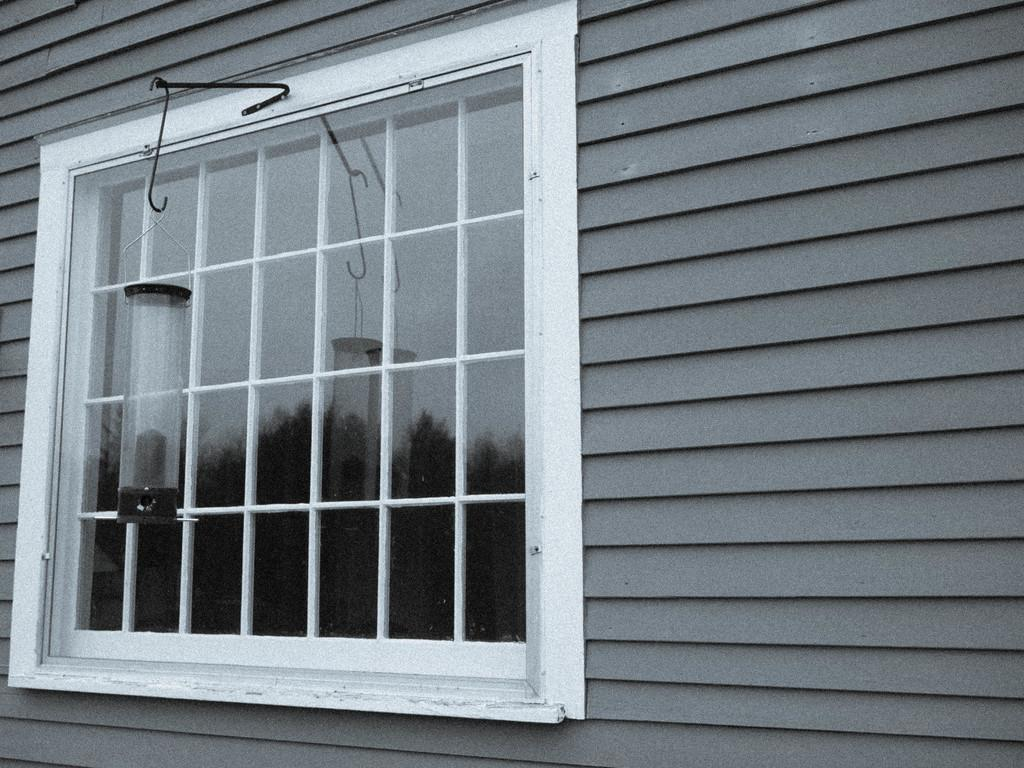What type of window is visible in the image? There is a white window in the image. What material is the window made of? The window has a glass. What other object can be seen hanging in the image? There is a lamp hanging in the image. Where is the stream located in the image? There is no stream present in the image. How many cherries are hanging from the lamp in the image? There are no cherries present in the image, and the lamp is not described as having cherries hanging from it. 